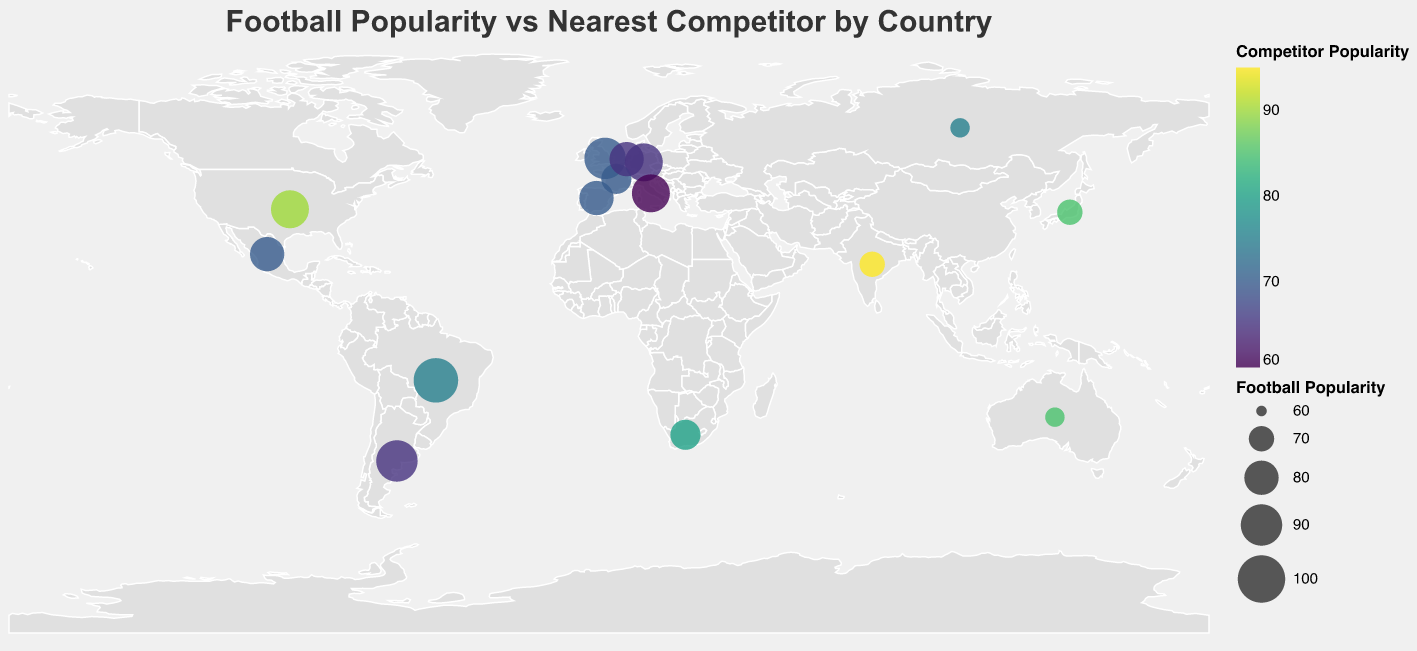What is the title of the figure? The title can be found at the top of the figure and it usually describes the main point of the visualization.
Answer: Football Popularity vs Nearest Competitor by Country How many countries have football as more popular than the nearest competitor sport? To answer this, count the number of countries where football popularity is higher than the competitor popularity.
Answer: 10 Which country has the least football popularity? Look at the data points and compare the values of football popularity to determine the smallest value.
Answer: Russia In which country is the popularity of football and its nearest competitor almost equal? Identify the countries where the difference between football popularity and the nearest competitor is minimal.
Answer: France Which country has the highest competitor popularity? Compare the competitor popularity values across all countries to find the maximum value.
Answer: India What is the average football popularity across all countries? Sum the football popularity values and divide by the number of countries (15). (85+95+90+85+80+85+75+90+80+70+75+65+70+65+80 = 1120; 1120 / 15 = 74.67)
Answer: 74.67 Which country has a higher popularity for its nearest competitor sport than football? Identify the countries where the competitor sport has higher popularity than football. These countries are marked differently and represented visually.
Answer: United States, Japan, South Africa, Australia, India, Russia What is the soccer (football) popularity rank for Brazil among the listed countries? Rank the countries based on their football popularity from highest to lowest. Brazil has an extremely high rank due to the very high popularity score of 95. (Brazil is 95, Argentina and England are both 90).
Answer: 1st 